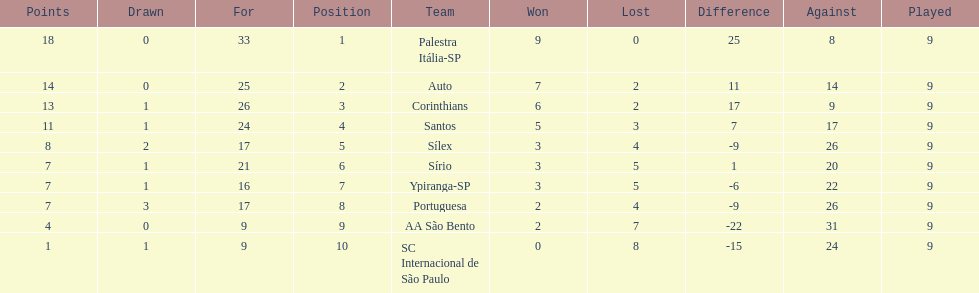In 1926 brazilian football,aside from the first place team, what other teams had winning records? Auto, Corinthians, Santos. 